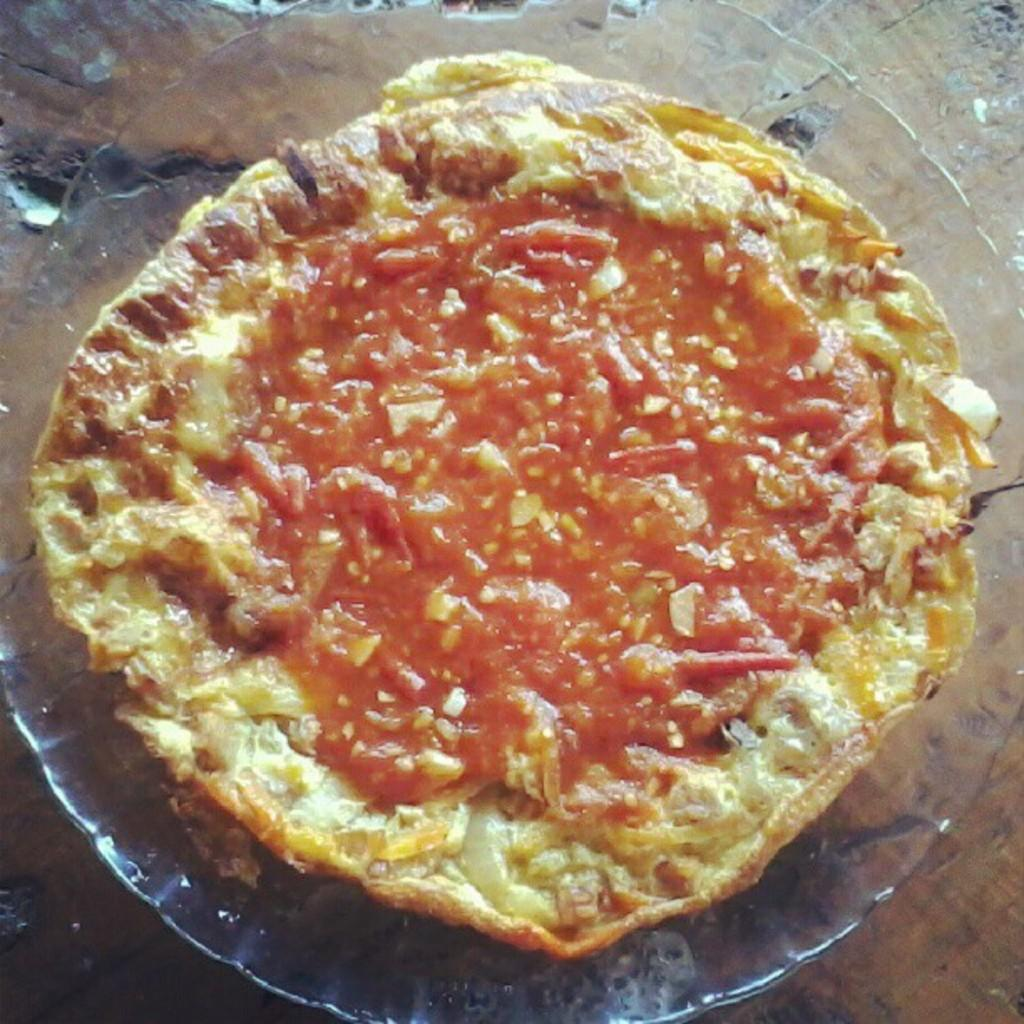What is the main subject of the image? There is a food item in the image. How is the food item presented in the image? The food item is on a plate. Where is the plate located in the image? The plate is in the center of the image. What is the rate at which the flock of birds is flying in the image? There are no birds present in the image, so it is not possible to determine the rate at which they might be flying. 